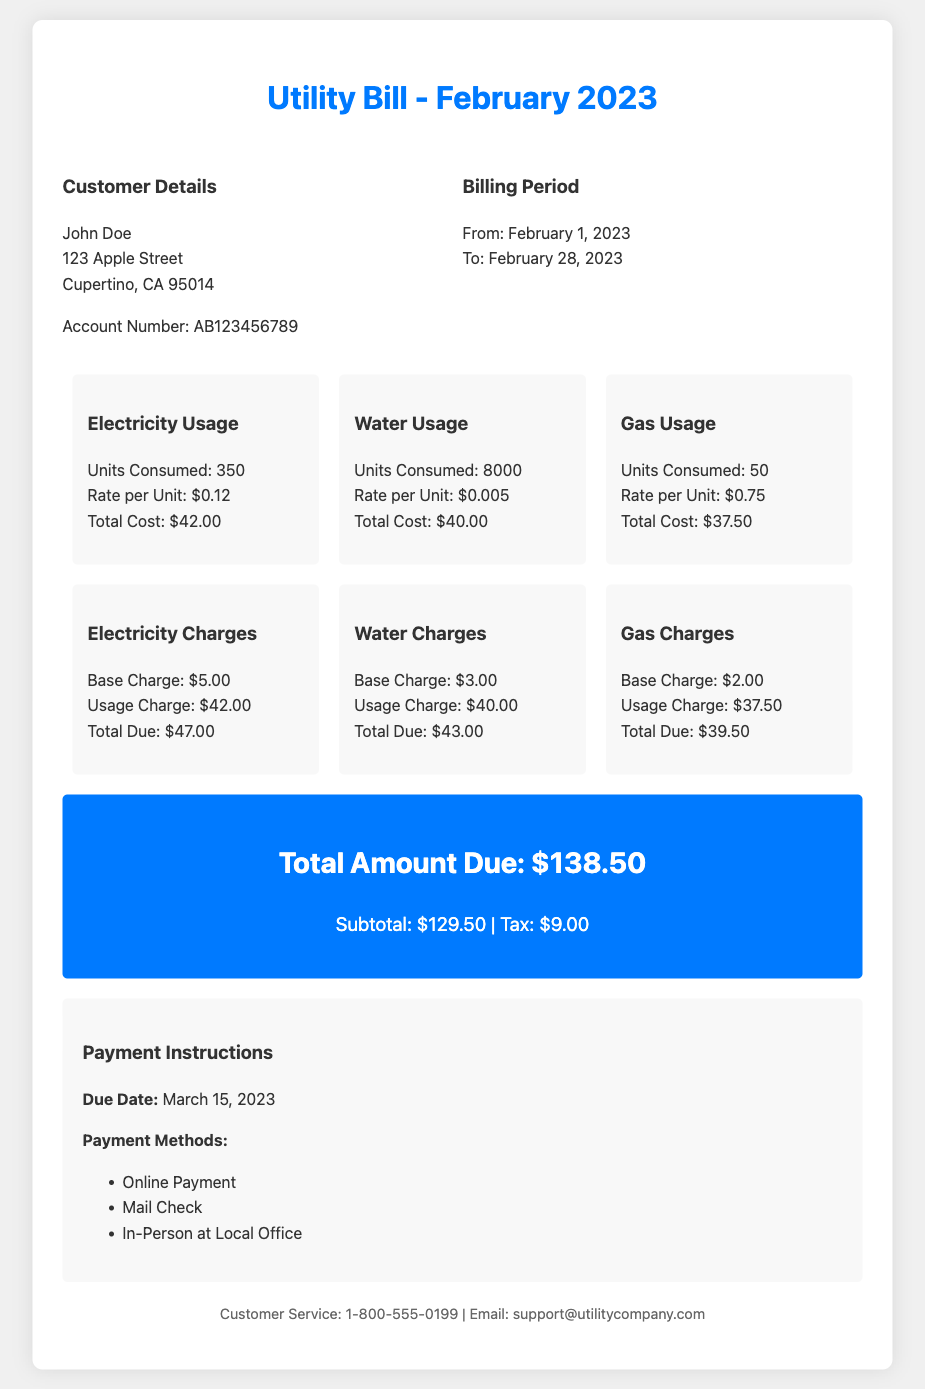What is the total amount due? The total amount due is stated in the document as the final billing amount.
Answer: $138.50 What are the units of electricity consumed? The units of electricity consumed is a specific detail provided in the usage summary section of the document.
Answer: 350 What is the base charge for gas? The base charge for gas is listed under the gas charges section of the breakdown.
Answer: $2.00 When is the due date for this payment? The due date for the payment is indicated clearly in the payment instructions section of the document.
Answer: March 15, 2023 How many units of water were used? The usage details in the document provide the number of water units consumed during the billing period.
Answer: 8000 What is the total cost for water? The total cost for water is calculated based on the units consumed and the rate per unit provided in the document.
Answer: $40.00 Which method of payment is mentioned first? The payment methods are listed in the payment instructions section, with the first method being the most prominent.
Answer: Online Payment What is the rate per unit for electricity? The rate per unit for electricity is provided in the electricity usage summary and is used to calculate the total cost.
Answer: $0.12 What is the subtotal amount before tax? The subtotal is mentioned in the total amount section, indicating the total charges before any taxes are applied.
Answer: $129.50 